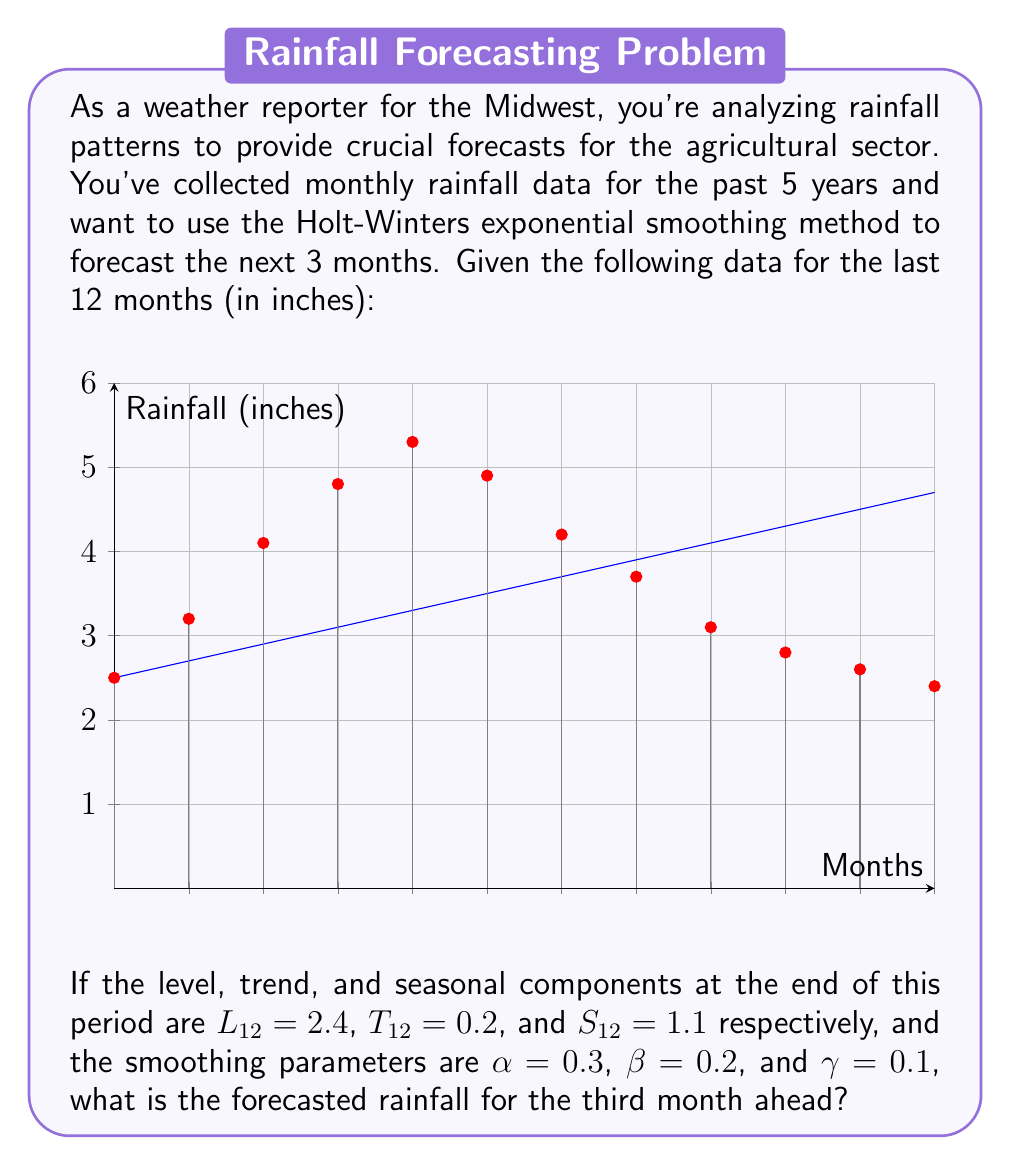Help me with this question. To solve this problem, we'll use the Holt-Winters additive method for time series forecasting. The formula for forecasting $m$ periods ahead is:

$$F_{t+m} = L_t + mT_t + S_{t-s+m}$$

Where:
- $F_{t+m}$ is the forecast for $m$ periods ahead
- $L_t$ is the level component at time $t$
- $T_t$ is the trend component at time $t$
- $S_{t-s+m}$ is the seasonal component, where $s$ is the length of the seasonal cycle

Given:
- $L_{12} = 2.4$ (level at the end of period 12)
- $T_{12} = 0.2$ (trend at the end of period 12)
- $S_{12} = 1.1$ (seasonal component for period 12)
- We want to forecast 3 months ahead, so $m = 3$

Steps:
1) We need to find $S_{12-12+3} = S_3$, which is the seasonal component for the 3rd month in the cycle.

2) Looking at the data, we can see that the 3rd month's rainfall is 4.1 inches. To estimate $S_3$, we can calculate the difference between this value and the trend line:

   $S_3 \approx 4.1 - (2.5 + 0.2 * 2) = 1.2$

3) Now we can plug these values into the formula:

   $F_{12+3} = L_{12} + 3T_{12} + S_3$
   
   $F_{15} = 2.4 + 3(0.2) + 1.2$

4) Calculating:
   
   $F_{15} = 2.4 + 0.6 + 1.2 = 4.2$

Therefore, the forecasted rainfall for the third month ahead is 4.2 inches.
Answer: 4.2 inches 